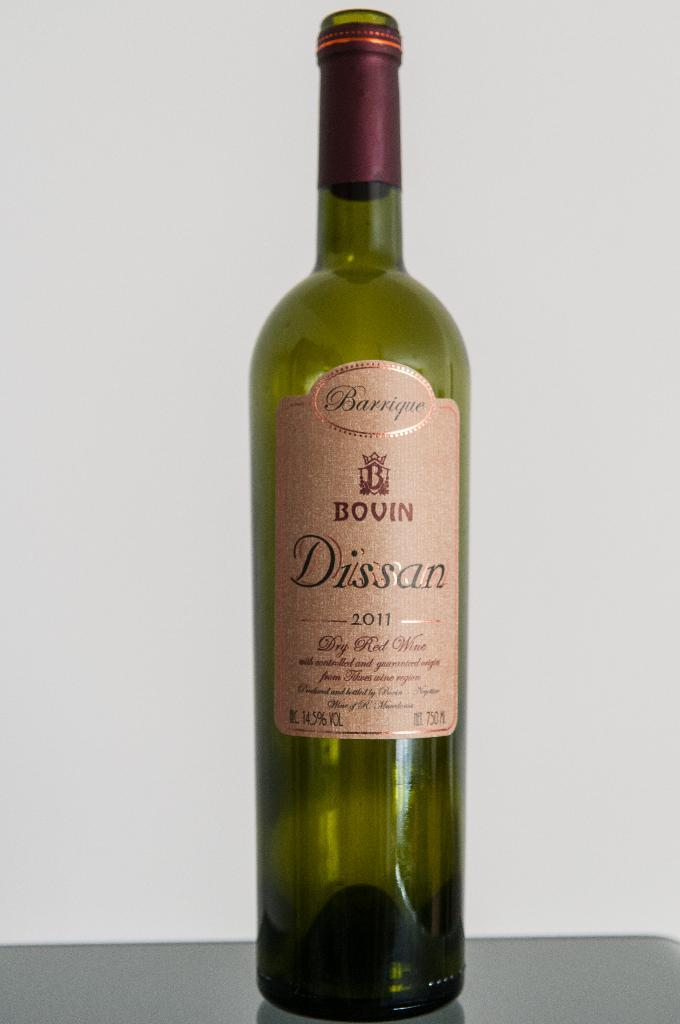What is the main object in the image? There is a wine bottle in the image. What can be seen on the wine bottle? The wine bottle has a sticker attached to it. What is the color of the surface the wine bottle is placed on? The wine bottle is on a grey color surface. What is the background color in the image? There is a white background in the image. How does the faucet compare to the wine bottle in the image? There is no faucet present in the image, so it cannot be compared to the wine bottle. 